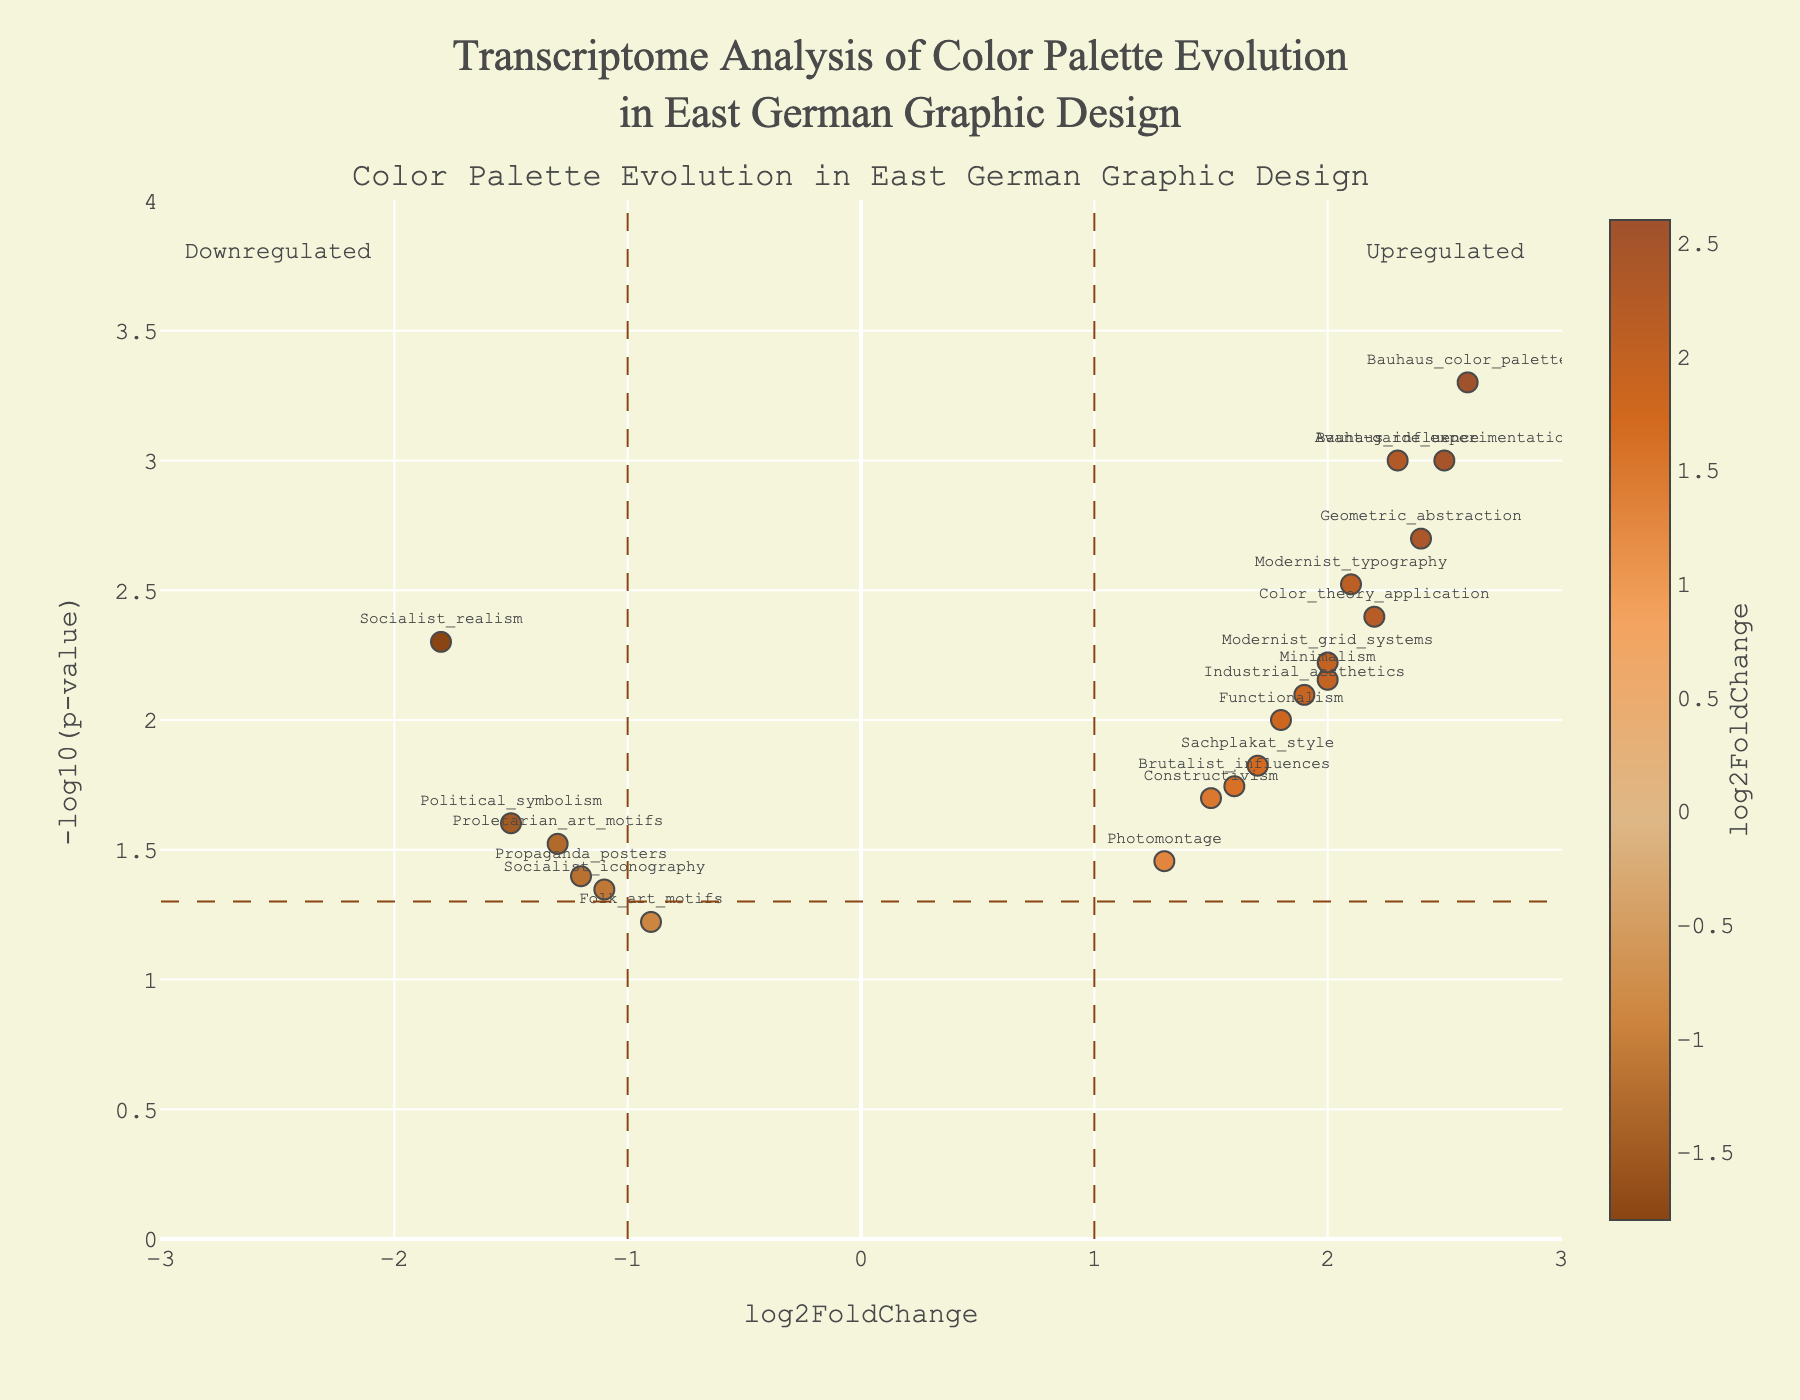What is the title of the figure? The title is usually placed at the top of the figure. In this case, it reads "Transcriptome Analysis of Color Palette Evolution in East German Graphic Design".
Answer: Transcriptome Analysis of Color Palette Evolution in East German Graphic Design How many data points represent a negative log2FoldChange? By observing the x-axis, which is labeled as log2FoldChange, and checking the positions of the points, we can see that 6 points lie to the left of zero, indicating negative log2FoldChange values.
Answer: 6 Which gene has the highest -log10(p-value)? By identifying the point that is plotted at the highest position along the y-axis labeled as "-log10(p-value)", we can see that "Bauhaus_color_palette" has the highest value.
Answer: Bauhaus_color_palette What's the range of log2FoldChange values? The range can be identified by noting the most negative and most positive log2FoldChange values. The lowest negative value is for "Socialist_realism" (-1.8) and the highest positive value is for "Bauhaus_color_palette" (2.6). The range is 2.6 - (-1.8).
Answer: 4.4 Which points are labeled as upregulated? Upregulated points are those with positive log2FoldChange values. By observing the x-axis and checking which points are to the right of the vertical line at zero, we can list them.
Answer: Bauhaus_influence, Constructivism, Modernist_typography, Industrial_aesthetics, Geometric_abstraction, Sachplakat_style, Minimalism, Photomontage, Color_theory_application, Brutalist_influences, Functionalism, Avant-garde_experimentation, Bauhaus_color_palette, Modernist_grid_systems What is the p-value threshold represented on the plot? The horizontal dashed line represents a p-value threshold. The y-axis is -log10(p-value), so the line's y-coordinate corresponds to -log10(0.05). This is approximately 1.3.
Answer: 0.05 Which genes have a log2FoldChange greater than 2 and are statistically significant? Points above the horizontal line at approximately 1.3 for -log10(p-value) and to the right of the vertical line at 2 for log2FoldChange indicate genes with log2FoldChange greater than 2 and significant p-values.
Answer: Bauhaus_influence, Bauhaus_color_palette, Avant-garde_experimentation, Color_theory_application What does the color of the points in the plot represent? Each point's color represents its log2FoldChange value. This is mapped to a specific color gradient, which is shown by the colorbar to the right of the plot.
Answer: log2FoldChange Which gene shows both the second highest log2FoldChange and statistically significant p-value? Observing the points on the right side of the plot, we look for the one just below the highest point with an x-axis value. "Avant-garde_experimentation" has the second highest log2FoldChange (2.5) and a significant p-value.
Answer: Avant-garde_experimentation 